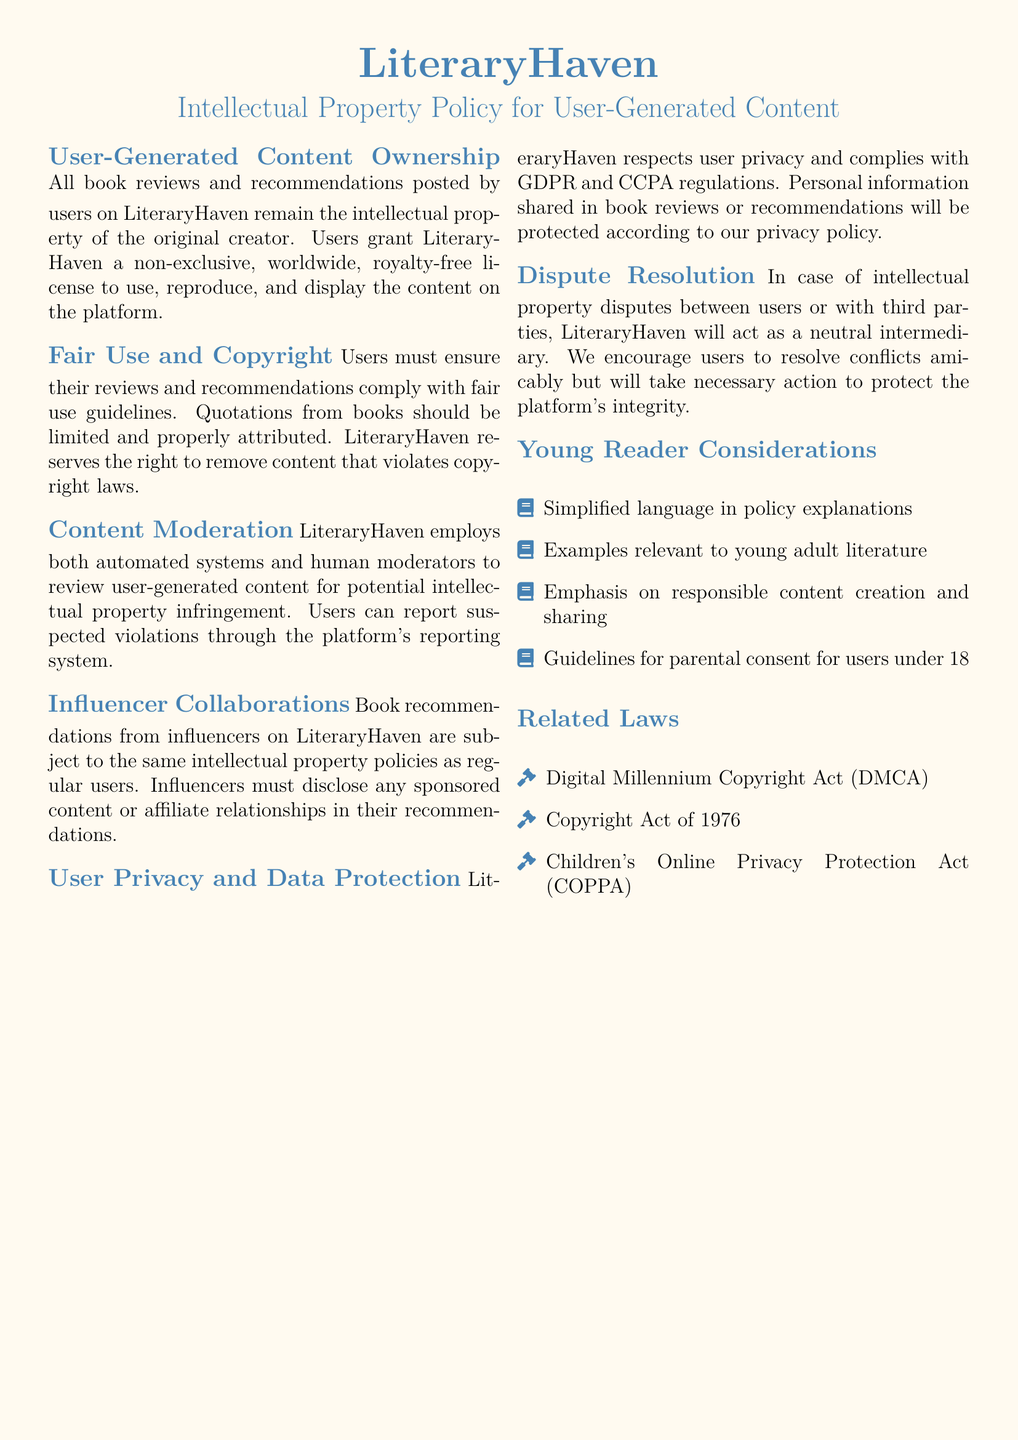What is the title of the document? The title of the document is prominently displayed at the top and is "Intellectual Property Policy for User-Generated Content."
Answer: Intellectual Property Policy for User-Generated Content Who owns the book reviews and recommendations posted by users? The document specifies that book reviews and recommendations remain the intellectual property of the original creator.
Answer: Original creator What kind of license do users grant LiteraryHaven for their content? The document states that users grant a non-exclusive, worldwide, royalty-free license to LiteraryHaven for their content.
Answer: Non-exclusive, worldwide, royalty-free license What act is referenced concerning children's online privacy? The document mentions the Children's Online Privacy Protection Act in the related laws section.
Answer: Children's Online Privacy Protection Act (COPPA) What is the mechanism for users to report content violations? The document indicates that users can report suspected violations through the platform's reporting system.
Answer: Reporting system How does LiteraryHaven handle content moderation? The document mentions that LiteraryHaven employs both automated systems and human moderators for content review.
Answer: Automated systems and human moderators What must influencers disclose in their recommendations? The document states that influencers must disclose any sponsored content or affiliate relationships in their recommendations.
Answer: Sponsored content or affiliate relationships Which regulation is mentioned regarding user privacy? The document specifies that LiteraryHaven complies with GDPR and CCPA regulations concerning user privacy.
Answer: GDPR and CCPA What is encouraged for resolving intellectual property disputes? The document encourages users to resolve conflicts amicably in case of disputes.
Answer: Resolve conflicts amicably 